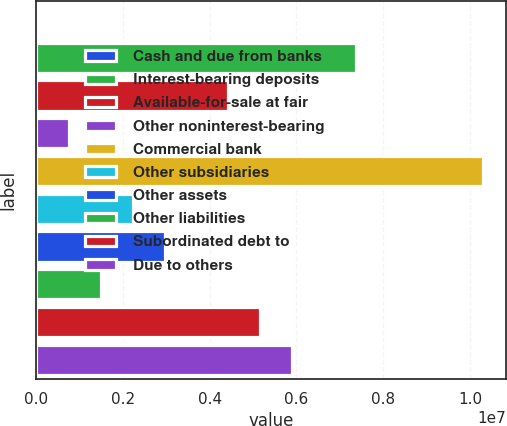Convert chart to OTSL. <chart><loc_0><loc_0><loc_500><loc_500><bar_chart><fcel>Cash and due from banks<fcel>Interest-bearing deposits<fcel>Available-for-sale at fair<fcel>Other noninterest-bearing<fcel>Commercial bank<fcel>Other subsidiaries<fcel>Other assets<fcel>Other liabilities<fcel>Subordinated debt to<fcel>Due to others<nl><fcel>23774<fcel>7.36953e+06<fcel>4.43123e+06<fcel>758350<fcel>1.03078e+07<fcel>2.2275e+06<fcel>2.96208e+06<fcel>1.49293e+06<fcel>5.1658e+06<fcel>5.90038e+06<nl></chart> 